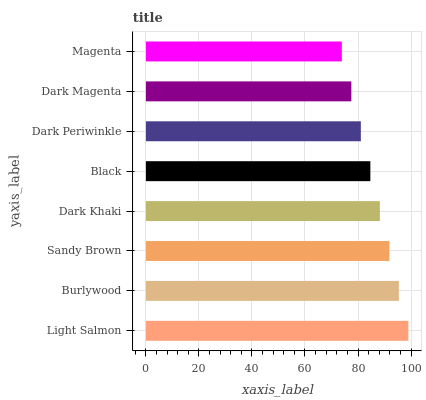Is Magenta the minimum?
Answer yes or no. Yes. Is Light Salmon the maximum?
Answer yes or no. Yes. Is Burlywood the minimum?
Answer yes or no. No. Is Burlywood the maximum?
Answer yes or no. No. Is Light Salmon greater than Burlywood?
Answer yes or no. Yes. Is Burlywood less than Light Salmon?
Answer yes or no. Yes. Is Burlywood greater than Light Salmon?
Answer yes or no. No. Is Light Salmon less than Burlywood?
Answer yes or no. No. Is Dark Khaki the high median?
Answer yes or no. Yes. Is Black the low median?
Answer yes or no. Yes. Is Dark Periwinkle the high median?
Answer yes or no. No. Is Dark Khaki the low median?
Answer yes or no. No. 